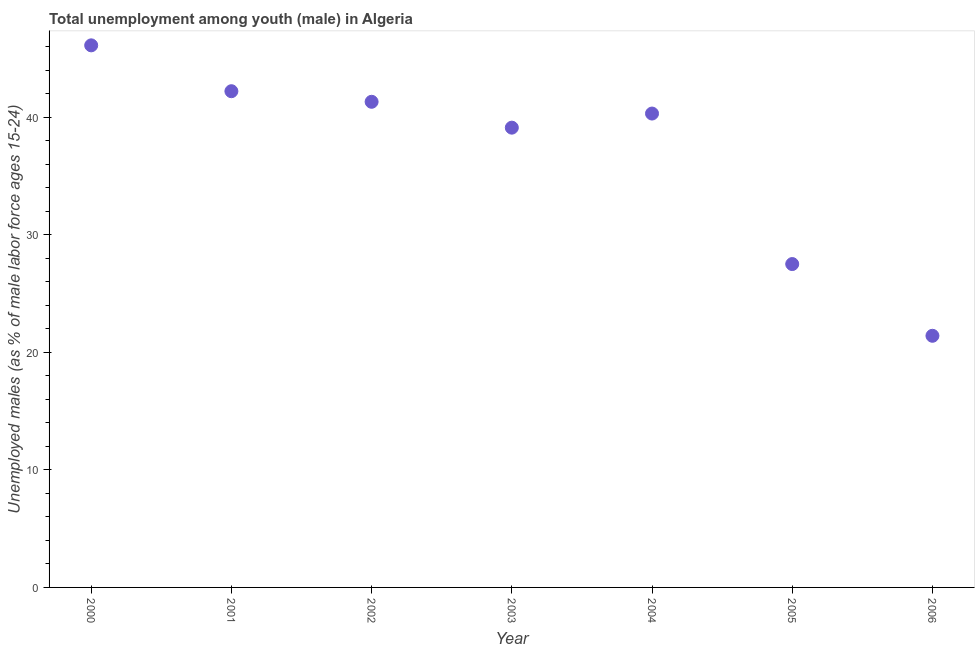What is the unemployed male youth population in 2002?
Give a very brief answer. 41.3. Across all years, what is the maximum unemployed male youth population?
Your response must be concise. 46.1. Across all years, what is the minimum unemployed male youth population?
Give a very brief answer. 21.4. In which year was the unemployed male youth population minimum?
Give a very brief answer. 2006. What is the sum of the unemployed male youth population?
Give a very brief answer. 257.9. What is the difference between the unemployed male youth population in 2001 and 2006?
Your response must be concise. 20.8. What is the average unemployed male youth population per year?
Provide a short and direct response. 36.84. What is the median unemployed male youth population?
Keep it short and to the point. 40.3. What is the ratio of the unemployed male youth population in 2001 to that in 2006?
Give a very brief answer. 1.97. Is the unemployed male youth population in 2003 less than that in 2006?
Ensure brevity in your answer.  No. What is the difference between the highest and the second highest unemployed male youth population?
Provide a succinct answer. 3.9. Is the sum of the unemployed male youth population in 2000 and 2004 greater than the maximum unemployed male youth population across all years?
Provide a short and direct response. Yes. What is the difference between the highest and the lowest unemployed male youth population?
Your answer should be very brief. 24.7. In how many years, is the unemployed male youth population greater than the average unemployed male youth population taken over all years?
Your response must be concise. 5. How many years are there in the graph?
Your answer should be very brief. 7. What is the difference between two consecutive major ticks on the Y-axis?
Keep it short and to the point. 10. Are the values on the major ticks of Y-axis written in scientific E-notation?
Provide a succinct answer. No. Does the graph contain grids?
Your response must be concise. No. What is the title of the graph?
Ensure brevity in your answer.  Total unemployment among youth (male) in Algeria. What is the label or title of the X-axis?
Your response must be concise. Year. What is the label or title of the Y-axis?
Keep it short and to the point. Unemployed males (as % of male labor force ages 15-24). What is the Unemployed males (as % of male labor force ages 15-24) in 2000?
Provide a succinct answer. 46.1. What is the Unemployed males (as % of male labor force ages 15-24) in 2001?
Ensure brevity in your answer.  42.2. What is the Unemployed males (as % of male labor force ages 15-24) in 2002?
Offer a terse response. 41.3. What is the Unemployed males (as % of male labor force ages 15-24) in 2003?
Give a very brief answer. 39.1. What is the Unemployed males (as % of male labor force ages 15-24) in 2004?
Offer a terse response. 40.3. What is the Unemployed males (as % of male labor force ages 15-24) in 2006?
Offer a very short reply. 21.4. What is the difference between the Unemployed males (as % of male labor force ages 15-24) in 2000 and 2003?
Your answer should be compact. 7. What is the difference between the Unemployed males (as % of male labor force ages 15-24) in 2000 and 2004?
Give a very brief answer. 5.8. What is the difference between the Unemployed males (as % of male labor force ages 15-24) in 2000 and 2006?
Give a very brief answer. 24.7. What is the difference between the Unemployed males (as % of male labor force ages 15-24) in 2001 and 2004?
Provide a short and direct response. 1.9. What is the difference between the Unemployed males (as % of male labor force ages 15-24) in 2001 and 2006?
Offer a very short reply. 20.8. What is the difference between the Unemployed males (as % of male labor force ages 15-24) in 2002 and 2003?
Provide a short and direct response. 2.2. What is the difference between the Unemployed males (as % of male labor force ages 15-24) in 2002 and 2004?
Make the answer very short. 1. What is the difference between the Unemployed males (as % of male labor force ages 15-24) in 2002 and 2005?
Provide a short and direct response. 13.8. What is the difference between the Unemployed males (as % of male labor force ages 15-24) in 2003 and 2004?
Provide a succinct answer. -1.2. What is the difference between the Unemployed males (as % of male labor force ages 15-24) in 2003 and 2005?
Provide a short and direct response. 11.6. What is the difference between the Unemployed males (as % of male labor force ages 15-24) in 2003 and 2006?
Ensure brevity in your answer.  17.7. What is the difference between the Unemployed males (as % of male labor force ages 15-24) in 2005 and 2006?
Offer a terse response. 6.1. What is the ratio of the Unemployed males (as % of male labor force ages 15-24) in 2000 to that in 2001?
Ensure brevity in your answer.  1.09. What is the ratio of the Unemployed males (as % of male labor force ages 15-24) in 2000 to that in 2002?
Offer a terse response. 1.12. What is the ratio of the Unemployed males (as % of male labor force ages 15-24) in 2000 to that in 2003?
Your response must be concise. 1.18. What is the ratio of the Unemployed males (as % of male labor force ages 15-24) in 2000 to that in 2004?
Provide a succinct answer. 1.14. What is the ratio of the Unemployed males (as % of male labor force ages 15-24) in 2000 to that in 2005?
Offer a very short reply. 1.68. What is the ratio of the Unemployed males (as % of male labor force ages 15-24) in 2000 to that in 2006?
Offer a terse response. 2.15. What is the ratio of the Unemployed males (as % of male labor force ages 15-24) in 2001 to that in 2003?
Give a very brief answer. 1.08. What is the ratio of the Unemployed males (as % of male labor force ages 15-24) in 2001 to that in 2004?
Provide a succinct answer. 1.05. What is the ratio of the Unemployed males (as % of male labor force ages 15-24) in 2001 to that in 2005?
Keep it short and to the point. 1.53. What is the ratio of the Unemployed males (as % of male labor force ages 15-24) in 2001 to that in 2006?
Provide a succinct answer. 1.97. What is the ratio of the Unemployed males (as % of male labor force ages 15-24) in 2002 to that in 2003?
Your answer should be compact. 1.06. What is the ratio of the Unemployed males (as % of male labor force ages 15-24) in 2002 to that in 2005?
Your answer should be very brief. 1.5. What is the ratio of the Unemployed males (as % of male labor force ages 15-24) in 2002 to that in 2006?
Offer a terse response. 1.93. What is the ratio of the Unemployed males (as % of male labor force ages 15-24) in 2003 to that in 2005?
Ensure brevity in your answer.  1.42. What is the ratio of the Unemployed males (as % of male labor force ages 15-24) in 2003 to that in 2006?
Offer a terse response. 1.83. What is the ratio of the Unemployed males (as % of male labor force ages 15-24) in 2004 to that in 2005?
Provide a short and direct response. 1.47. What is the ratio of the Unemployed males (as % of male labor force ages 15-24) in 2004 to that in 2006?
Keep it short and to the point. 1.88. What is the ratio of the Unemployed males (as % of male labor force ages 15-24) in 2005 to that in 2006?
Provide a short and direct response. 1.28. 